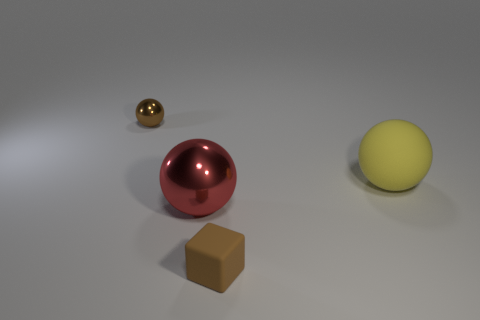Are there any gray shiny cylinders that have the same size as the block?
Make the answer very short. No. There is a brown cube that is the same size as the brown metal ball; what is it made of?
Keep it short and to the point. Rubber. Do the red metallic sphere and the brown thing that is to the right of the tiny brown metal object have the same size?
Your response must be concise. No. What is the big object that is left of the brown block made of?
Provide a short and direct response. Metal. Is the number of red things that are in front of the tiny brown shiny ball the same as the number of large red objects?
Give a very brief answer. Yes. Is the yellow object the same size as the red shiny ball?
Your response must be concise. Yes. Are there any shiny spheres behind the ball that is to the right of the matte cube that is on the right side of the big metallic object?
Ensure brevity in your answer.  Yes. What material is the large yellow object that is the same shape as the brown metal object?
Ensure brevity in your answer.  Rubber. How many large objects are left of the tiny thing in front of the tiny metal ball?
Provide a succinct answer. 1. What is the size of the brown thing that is behind the tiny thing right of the tiny brown object that is behind the tiny rubber thing?
Ensure brevity in your answer.  Small. 